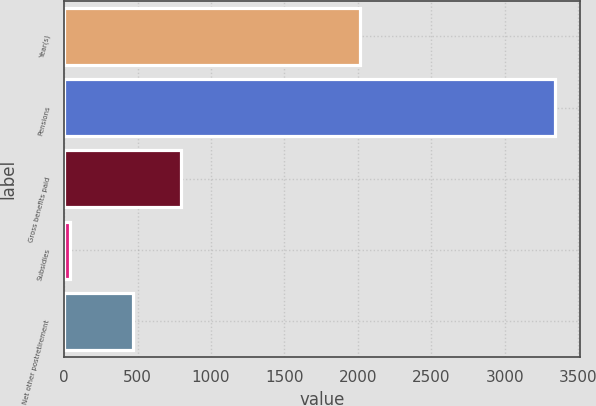<chart> <loc_0><loc_0><loc_500><loc_500><bar_chart><fcel>Year(s)<fcel>Pensions<fcel>Gross benefits paid<fcel>Subsidies<fcel>Net other postretirement<nl><fcel>2015<fcel>3346<fcel>796.5<fcel>41<fcel>466<nl></chart> 